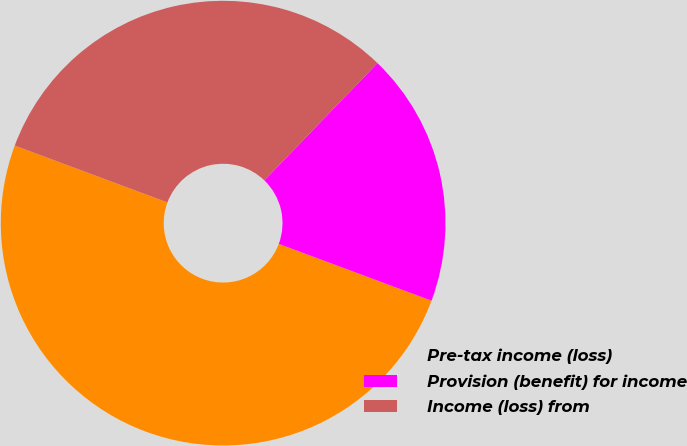<chart> <loc_0><loc_0><loc_500><loc_500><pie_chart><fcel>Pre-tax income (loss)<fcel>Provision (benefit) for income<fcel>Income (loss) from<nl><fcel>50.0%<fcel>18.46%<fcel>31.54%<nl></chart> 